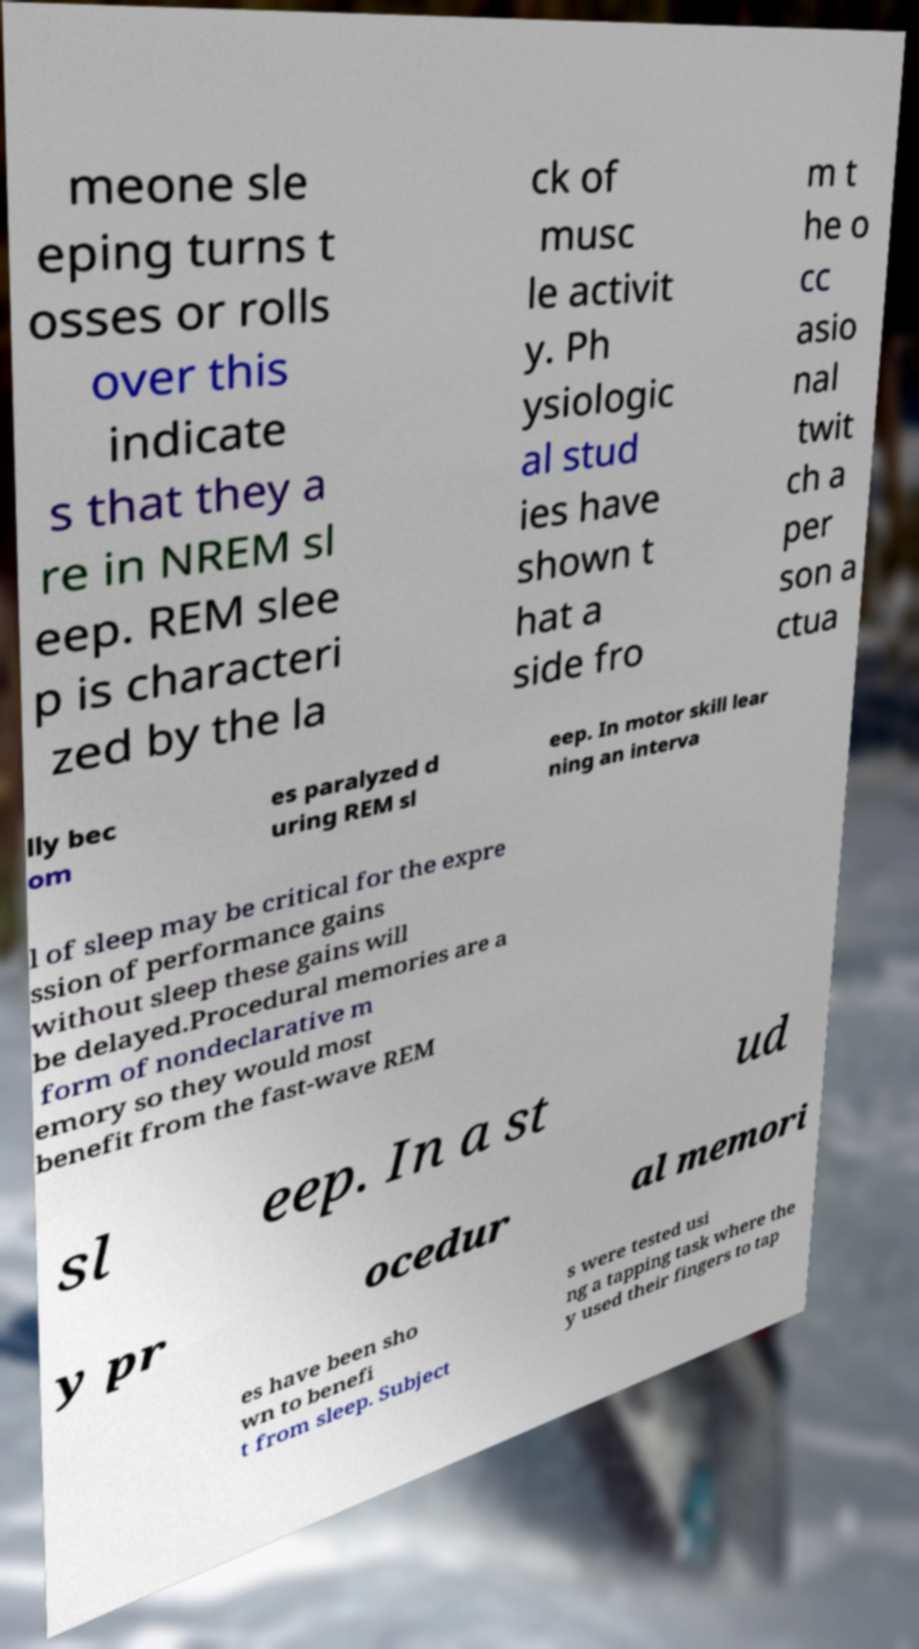For documentation purposes, I need the text within this image transcribed. Could you provide that? meone sle eping turns t osses or rolls over this indicate s that they a re in NREM sl eep. REM slee p is characteri zed by the la ck of musc le activit y. Ph ysiologic al stud ies have shown t hat a side fro m t he o cc asio nal twit ch a per son a ctua lly bec om es paralyzed d uring REM sl eep. In motor skill lear ning an interva l of sleep may be critical for the expre ssion of performance gains without sleep these gains will be delayed.Procedural memories are a form of nondeclarative m emory so they would most benefit from the fast-wave REM sl eep. In a st ud y pr ocedur al memori es have been sho wn to benefi t from sleep. Subject s were tested usi ng a tapping task where the y used their fingers to tap 